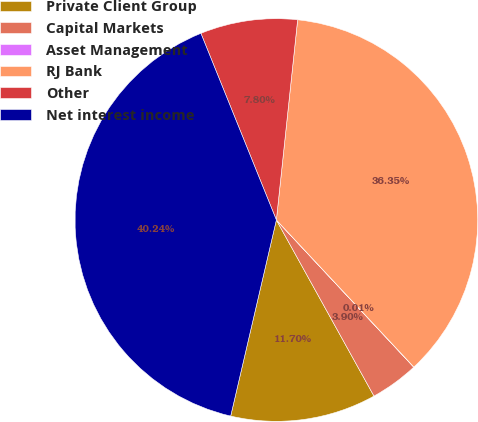Convert chart to OTSL. <chart><loc_0><loc_0><loc_500><loc_500><pie_chart><fcel>Private Client Group<fcel>Capital Markets<fcel>Asset Management<fcel>RJ Bank<fcel>Other<fcel>Net interest income<nl><fcel>11.7%<fcel>3.9%<fcel>0.01%<fcel>36.35%<fcel>7.8%<fcel>40.24%<nl></chart> 